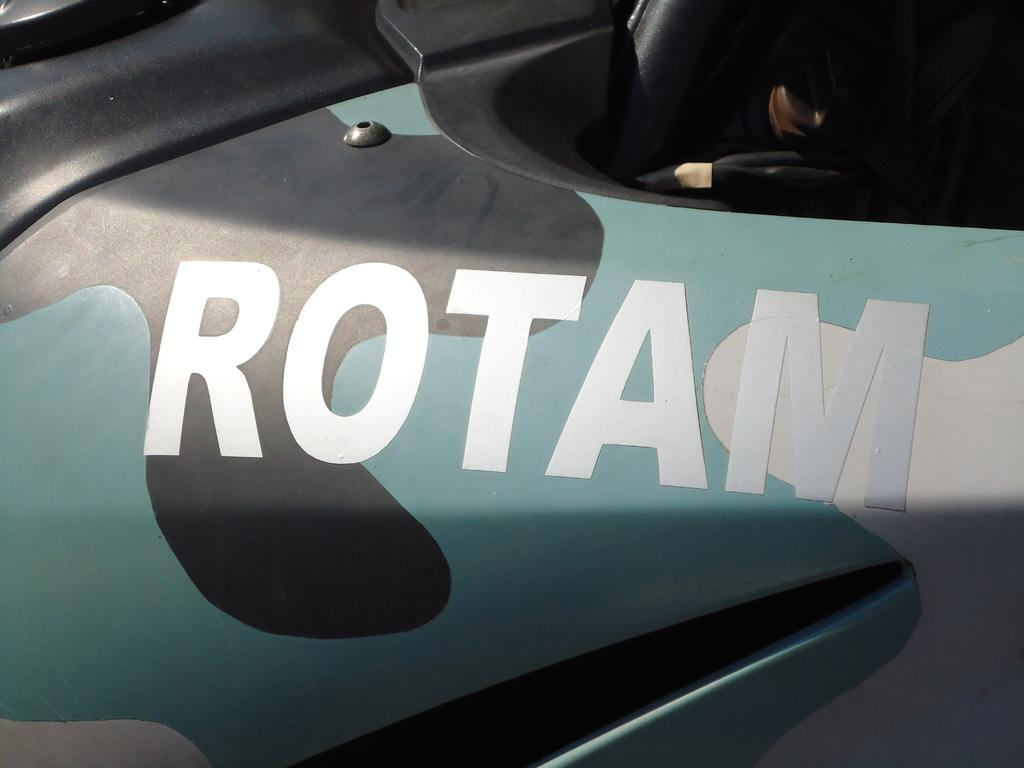What is the main subject of the image? There is an object in the image that resembles a vehicle. Can you describe any specific features of the vehicle? There is text visible on the object. How does the vehicle comb its hair in the image? There is no indication in the image that the vehicle has hair or is capable of combing it. 